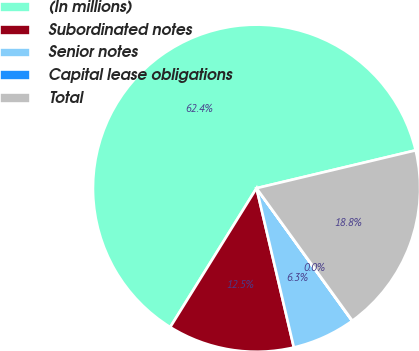<chart> <loc_0><loc_0><loc_500><loc_500><pie_chart><fcel>(In millions)<fcel>Subordinated notes<fcel>Senior notes<fcel>Capital lease obligations<fcel>Total<nl><fcel>62.43%<fcel>12.51%<fcel>6.27%<fcel>0.03%<fcel>18.75%<nl></chart> 